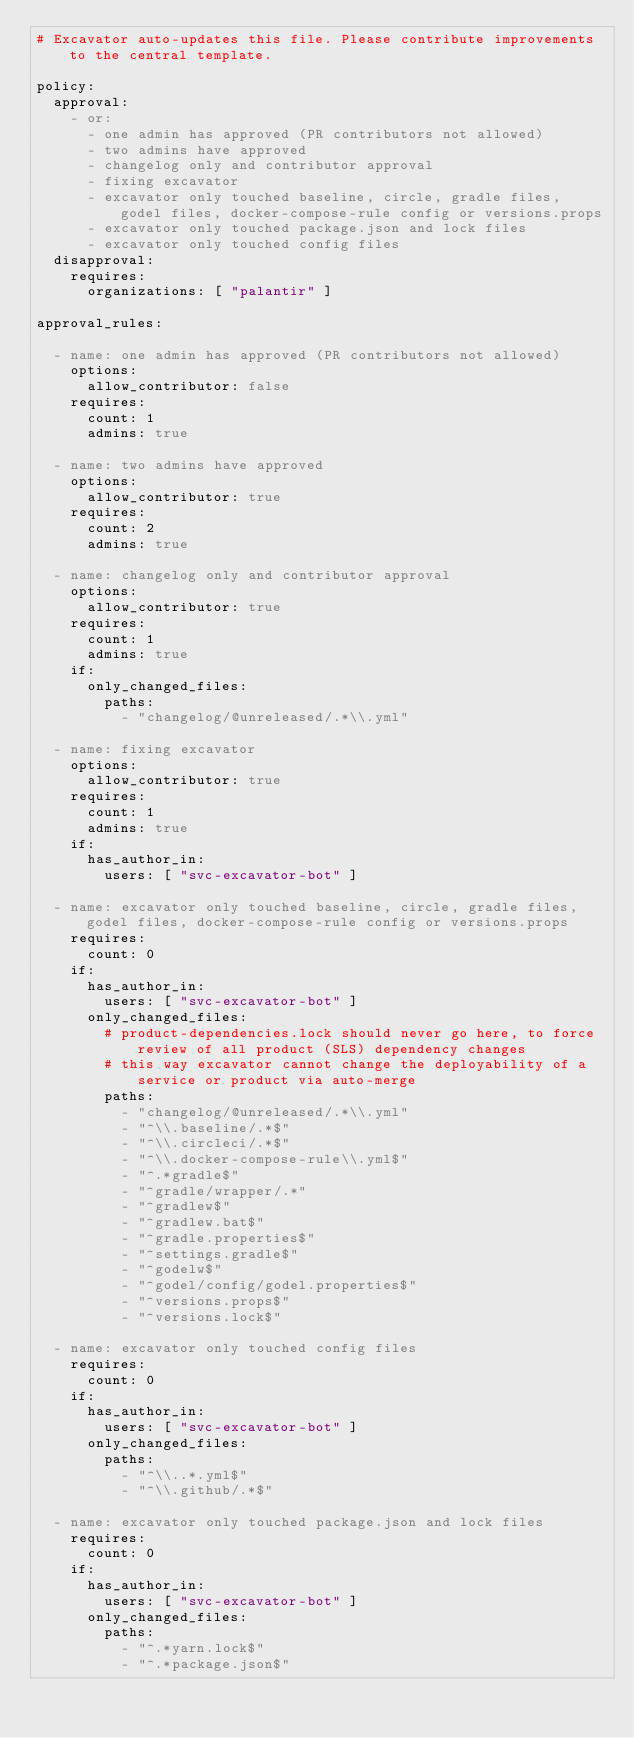<code> <loc_0><loc_0><loc_500><loc_500><_YAML_># Excavator auto-updates this file. Please contribute improvements to the central template.

policy:
  approval:
    - or:
      - one admin has approved (PR contributors not allowed)
      - two admins have approved
      - changelog only and contributor approval
      - fixing excavator
      - excavator only touched baseline, circle, gradle files, godel files, docker-compose-rule config or versions.props
      - excavator only touched package.json and lock files
      - excavator only touched config files
  disapproval:
    requires:
      organizations: [ "palantir" ]

approval_rules:

  - name: one admin has approved (PR contributors not allowed)
    options:
      allow_contributor: false
    requires:
      count: 1
      admins: true

  - name: two admins have approved
    options:
      allow_contributor: true
    requires:
      count: 2
      admins: true

  - name: changelog only and contributor approval
    options:
      allow_contributor: true
    requires:
      count: 1
      admins: true
    if:
      only_changed_files:
        paths:
          - "changelog/@unreleased/.*\\.yml"

  - name: fixing excavator
    options:
      allow_contributor: true
    requires:
      count: 1
      admins: true
    if:
      has_author_in:
        users: [ "svc-excavator-bot" ]

  - name: excavator only touched baseline, circle, gradle files, godel files, docker-compose-rule config or versions.props
    requires:
      count: 0
    if:
      has_author_in:
        users: [ "svc-excavator-bot" ]
      only_changed_files:
        # product-dependencies.lock should never go here, to force review of all product (SLS) dependency changes
        # this way excavator cannot change the deployability of a service or product via auto-merge
        paths:
          - "changelog/@unreleased/.*\\.yml"
          - "^\\.baseline/.*$"
          - "^\\.circleci/.*$"
          - "^\\.docker-compose-rule\\.yml$"
          - "^.*gradle$"
          - "^gradle/wrapper/.*"
          - "^gradlew$"
          - "^gradlew.bat$"
          - "^gradle.properties$"
          - "^settings.gradle$"
          - "^godelw$"
          - "^godel/config/godel.properties$"
          - "^versions.props$"
          - "^versions.lock$"

  - name: excavator only touched config files
    requires:
      count: 0
    if:
      has_author_in:
        users: [ "svc-excavator-bot" ]
      only_changed_files:
        paths:
          - "^\\..*.yml$"
          - "^\\.github/.*$"

  - name: excavator only touched package.json and lock files
    requires:
      count: 0
    if:
      has_author_in:
        users: [ "svc-excavator-bot" ]
      only_changed_files:
        paths:
          - "^.*yarn.lock$"
          - "^.*package.json$"
</code> 